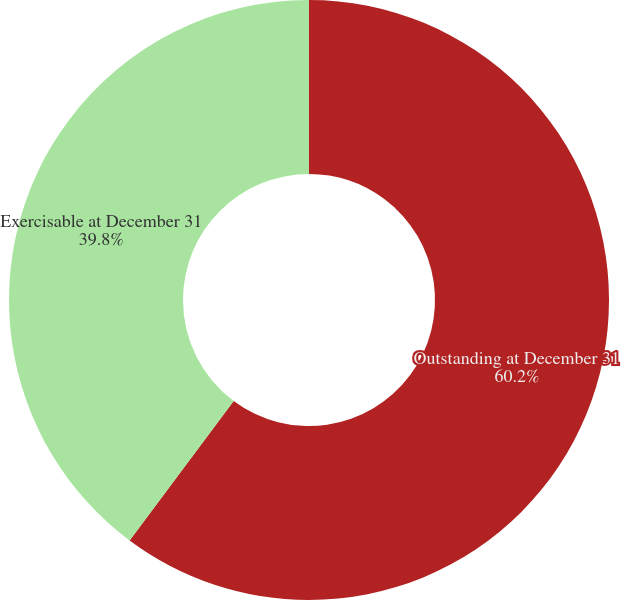Convert chart to OTSL. <chart><loc_0><loc_0><loc_500><loc_500><pie_chart><fcel>Outstanding at December 31<fcel>Exercisable at December 31<nl><fcel>60.2%<fcel>39.8%<nl></chart> 